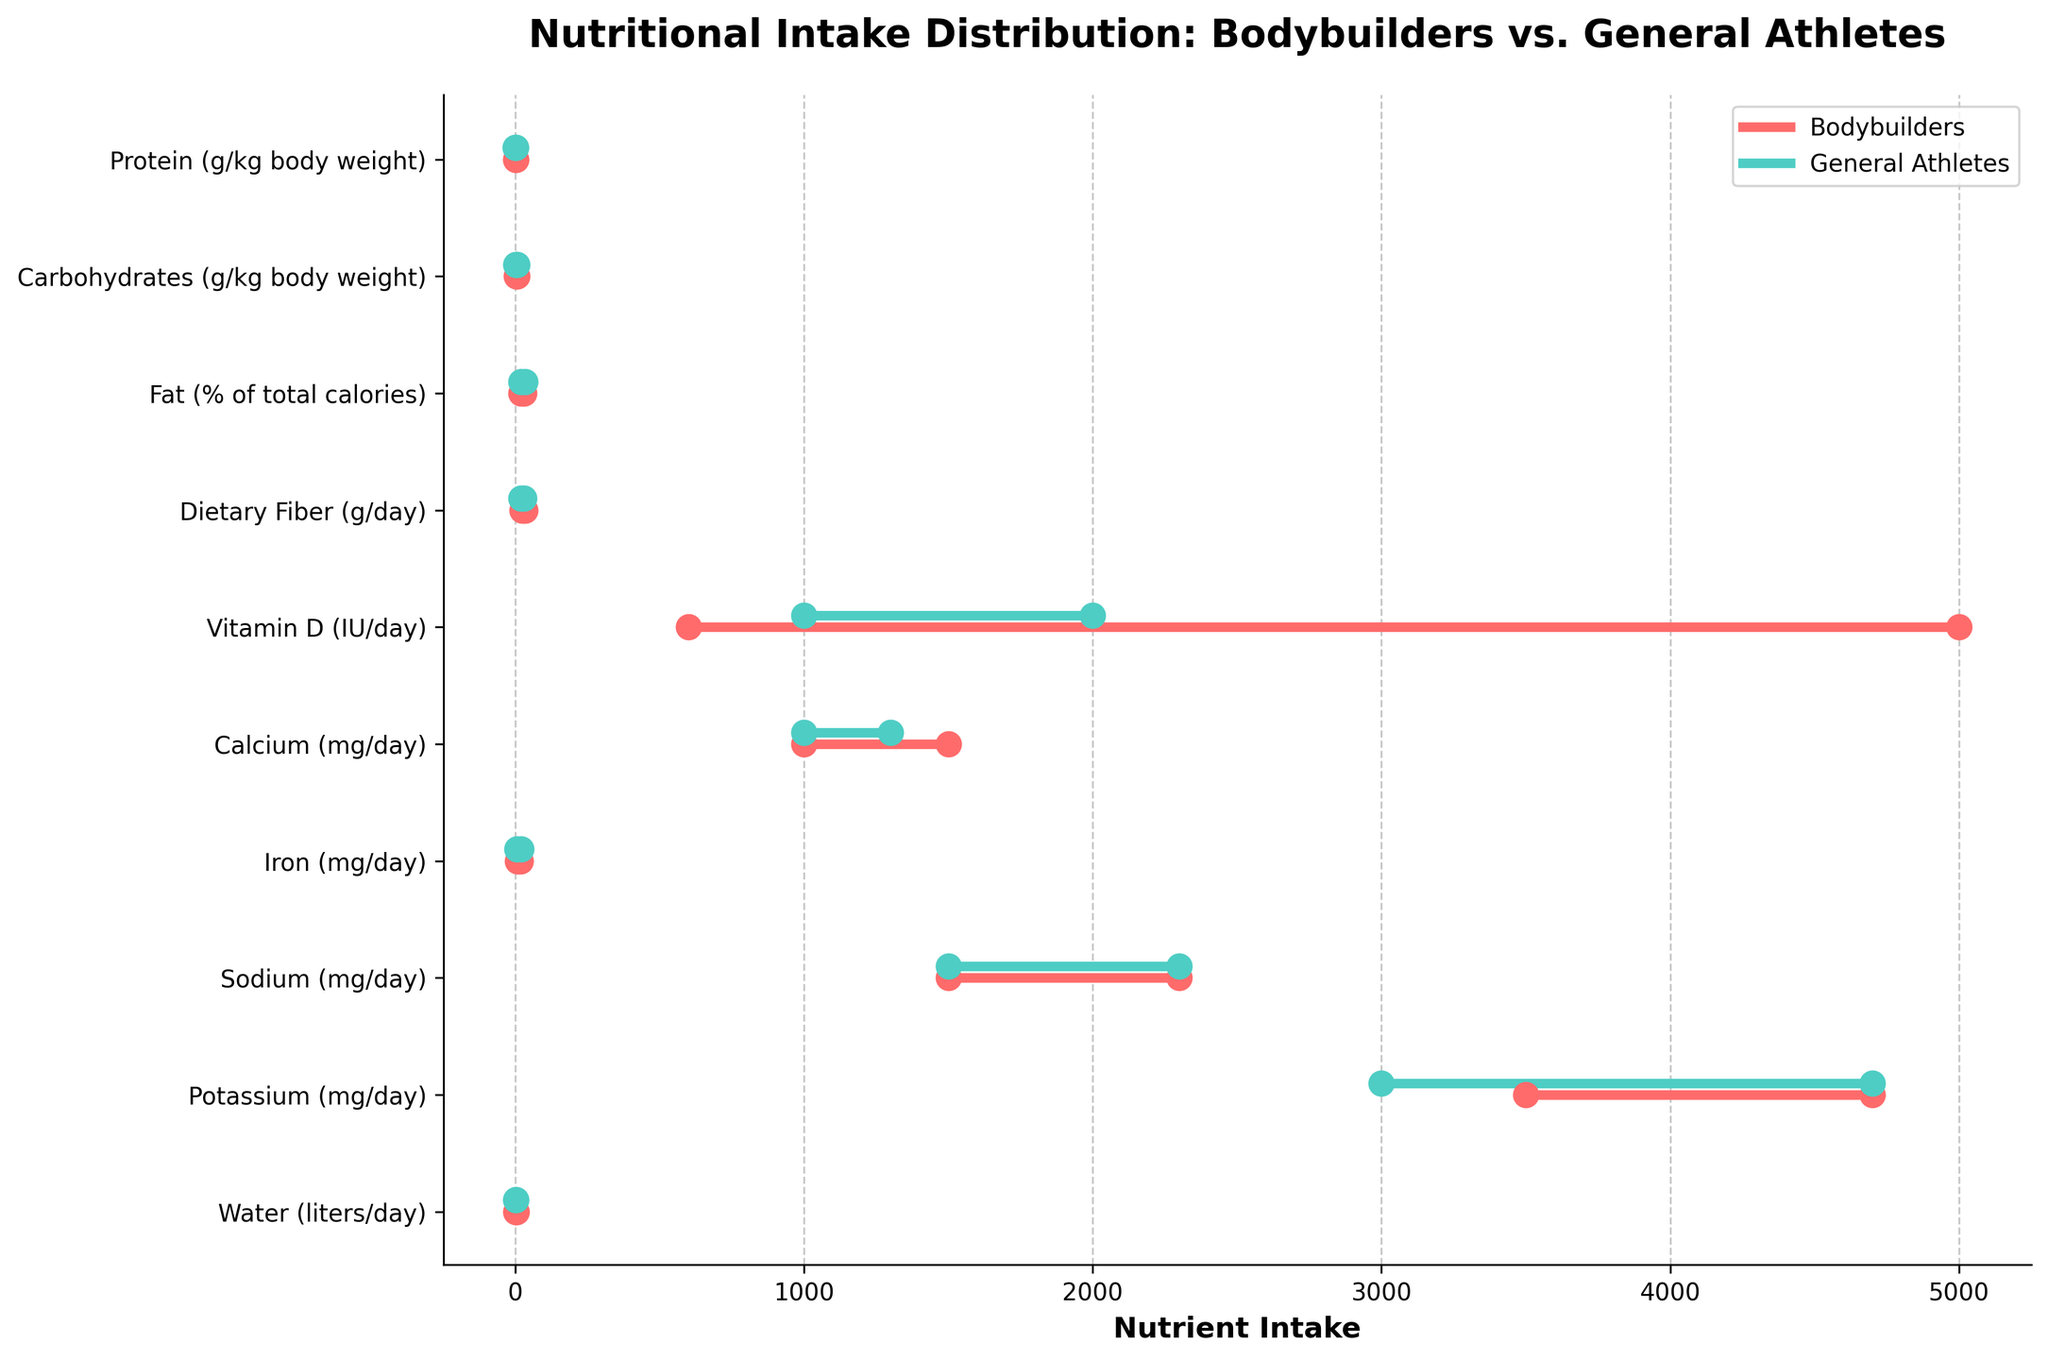Which group has a higher minimum intake of protein? Compare the minimum protein intake values for bodybuilders (2.2g/kg) and general athletes (1.2g/kg). Identify which is higher.
Answer: Bodybuilders What is the range of carbohydrate intake for general athletes? Subtract the minimum carbohydrate intake value (3.0g/kg) from the maximum (6.0g/kg) for general athletes.
Answer: 3.0 How does the maximum iron intake for bodybuilders compare to that of general athletes? Compare the maximum iron intake values: Bodybuilders (18 mg/day) vs. General Athletes (20 mg/day).
Answer: Less What is the difference in the maximum recommended intake of Vitamin D between bodybuilders and general athletes? Subtract the maximum Vitamin D intake for general athletes (2000 IU/day) from that of bodybuilders (5000 IU/day).
Answer: 3000 Which nutrient has the same range for both bodybuilders and general athletes? Check all nutrients for identical minimum and maximum intake values for both groups. Sodium has both min and max values identical.
Answer: Sodium Which group has a greater range for water intake? Calculate the range for both groups: Bodybuilders (4.0 - 3.0 = 1.0 liters), General Athletes (3.5 - 2.5 = 1.0 liters). Both have the same range.
Answer: Equal What nutrient does bodybuilders have a wider range of intake compared to general athletes? Compare the range (max-min) of each nutrient. E.g., Vitamin D: Bodybuilders (5000 IU - 600 IU = 4400 IU), General Athletes (2000 IU - 1000 IU = 1000 IU). Vitamin D has the largest difference.
Answer: Vitamin D Which group has a higher average intake of carbohydrates? Calculate averages for carbohydrate intake: Bodybuilders ([4.0 + 7.0]/2 = 5.5 g/kg), General Athletes ([3.0 + 6.0]/2 = 4.5 g/kg). Compare the averages.
Answer: Bodybuilders 